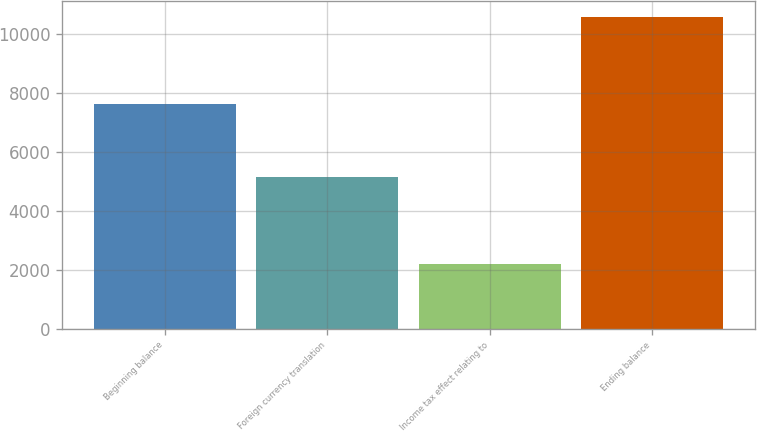<chart> <loc_0><loc_0><loc_500><loc_500><bar_chart><fcel>Beginning balance<fcel>Foreign currency translation<fcel>Income tax effect relating to<fcel>Ending balance<nl><fcel>7632<fcel>5156<fcel>2208<fcel>10580<nl></chart> 